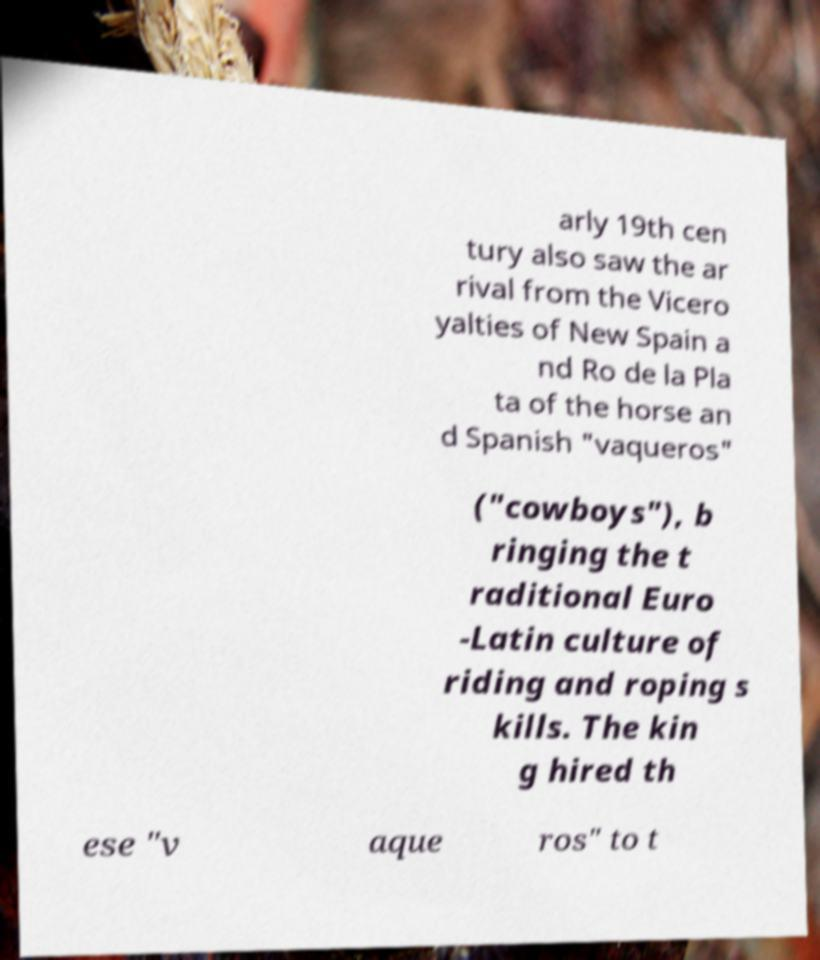What messages or text are displayed in this image? I need them in a readable, typed format. arly 19th cen tury also saw the ar rival from the Vicero yalties of New Spain a nd Ro de la Pla ta of the horse an d Spanish "vaqueros" ("cowboys"), b ringing the t raditional Euro -Latin culture of riding and roping s kills. The kin g hired th ese "v aque ros" to t 